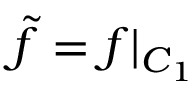Convert formula to latex. <formula><loc_0><loc_0><loc_500><loc_500>\tilde { f } = f | _ { C _ { 1 } }</formula> 